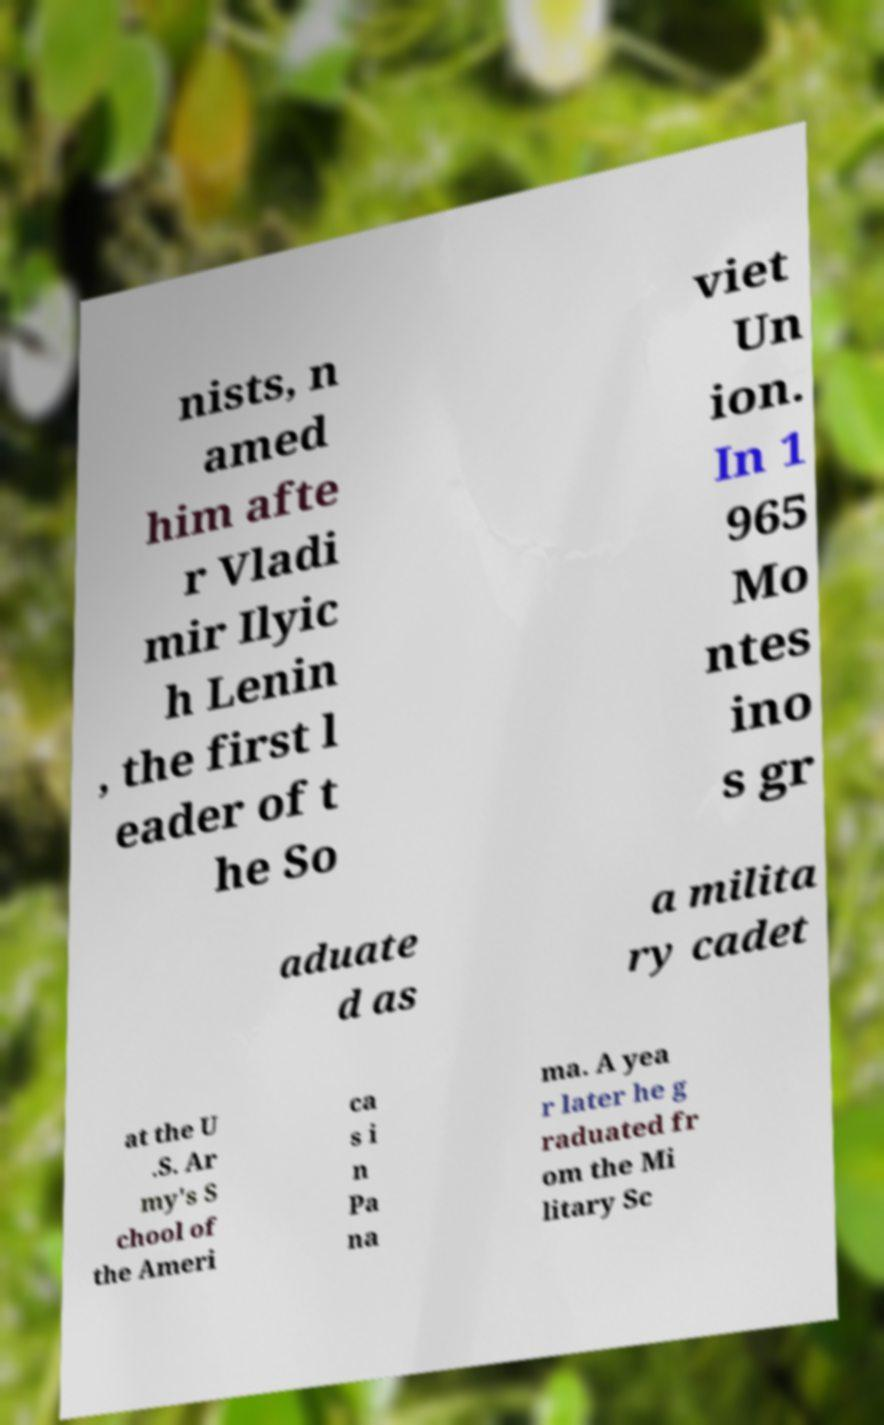What messages or text are displayed in this image? I need them in a readable, typed format. nists, n amed him afte r Vladi mir Ilyic h Lenin , the first l eader of t he So viet Un ion. In 1 965 Mo ntes ino s gr aduate d as a milita ry cadet at the U .S. Ar my's S chool of the Ameri ca s i n Pa na ma. A yea r later he g raduated fr om the Mi litary Sc 